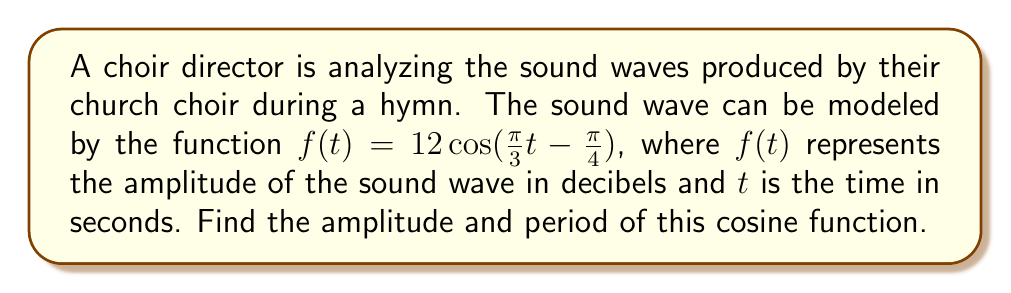What is the answer to this math problem? To find the amplitude and period of the given cosine function, we need to analyze its general form:

$$f(t) = A\cos(B(t - C)) + D$$

where:
$A$ is the amplitude
$B$ is related to the period
$C$ is the phase shift
$D$ is the vertical shift

In our case, we have:

$$f(t) = 12\cos(\frac{\pi}{3}t - \frac{\pi}{4})$$

Step 1: Identify the amplitude
The amplitude is the coefficient in front of the cosine function. Here, $A = 12$.

Step 2: Find the period
For a cosine function in the form $\cos(Bt)$, the period is given by:

$$\text{Period} = \frac{2\pi}{|B|}$$

In our function, $B = \frac{\pi}{3}$. Therefore:

$$\text{Period} = \frac{2\pi}{|\frac{\pi}{3}|} = \frac{2\pi}{\frac{\pi}{3}} = 2 \cdot 3 = 6$$

Thus, the period is 6 seconds.
Answer: Amplitude: 12 decibels
Period: 6 seconds 